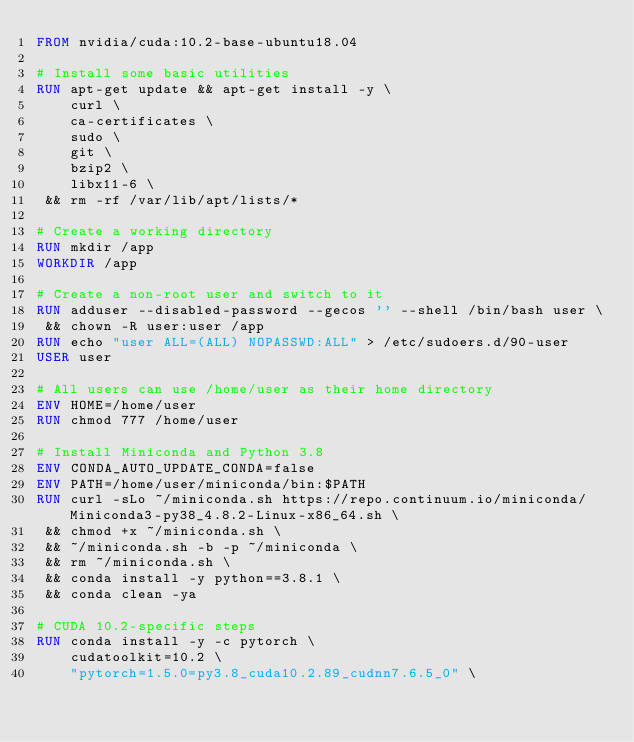Convert code to text. <code><loc_0><loc_0><loc_500><loc_500><_Dockerfile_>FROM nvidia/cuda:10.2-base-ubuntu18.04

# Install some basic utilities
RUN apt-get update && apt-get install -y \
    curl \
    ca-certificates \
    sudo \
    git \
    bzip2 \
    libx11-6 \
 && rm -rf /var/lib/apt/lists/*

# Create a working directory
RUN mkdir /app
WORKDIR /app

# Create a non-root user and switch to it
RUN adduser --disabled-password --gecos '' --shell /bin/bash user \
 && chown -R user:user /app
RUN echo "user ALL=(ALL) NOPASSWD:ALL" > /etc/sudoers.d/90-user
USER user

# All users can use /home/user as their home directory
ENV HOME=/home/user
RUN chmod 777 /home/user

# Install Miniconda and Python 3.8
ENV CONDA_AUTO_UPDATE_CONDA=false
ENV PATH=/home/user/miniconda/bin:$PATH
RUN curl -sLo ~/miniconda.sh https://repo.continuum.io/miniconda/Miniconda3-py38_4.8.2-Linux-x86_64.sh \
 && chmod +x ~/miniconda.sh \
 && ~/miniconda.sh -b -p ~/miniconda \
 && rm ~/miniconda.sh \
 && conda install -y python==3.8.1 \
 && conda clean -ya

# CUDA 10.2-specific steps
RUN conda install -y -c pytorch \
    cudatoolkit=10.2 \
    "pytorch=1.5.0=py3.8_cuda10.2.89_cudnn7.6.5_0" \</code> 